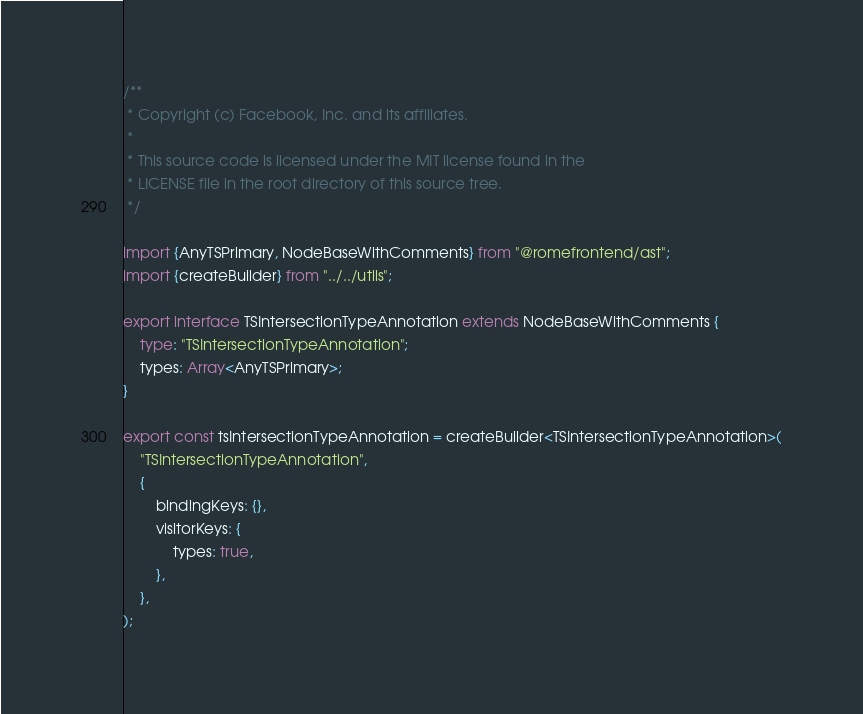Convert code to text. <code><loc_0><loc_0><loc_500><loc_500><_TypeScript_>/**
 * Copyright (c) Facebook, Inc. and its affiliates.
 *
 * This source code is licensed under the MIT license found in the
 * LICENSE file in the root directory of this source tree.
 */

import {AnyTSPrimary, NodeBaseWithComments} from "@romefrontend/ast";
import {createBuilder} from "../../utils";

export interface TSIntersectionTypeAnnotation extends NodeBaseWithComments {
	type: "TSIntersectionTypeAnnotation";
	types: Array<AnyTSPrimary>;
}

export const tsIntersectionTypeAnnotation = createBuilder<TSIntersectionTypeAnnotation>(
	"TSIntersectionTypeAnnotation",
	{
		bindingKeys: {},
		visitorKeys: {
			types: true,
		},
	},
);
</code> 